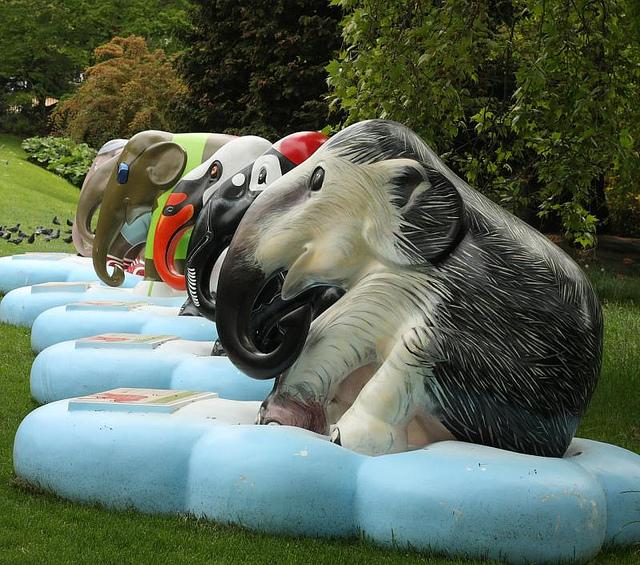How would these animals be described?

Choices:
A) canine
B) human made
C) feline
D) bovine human made 